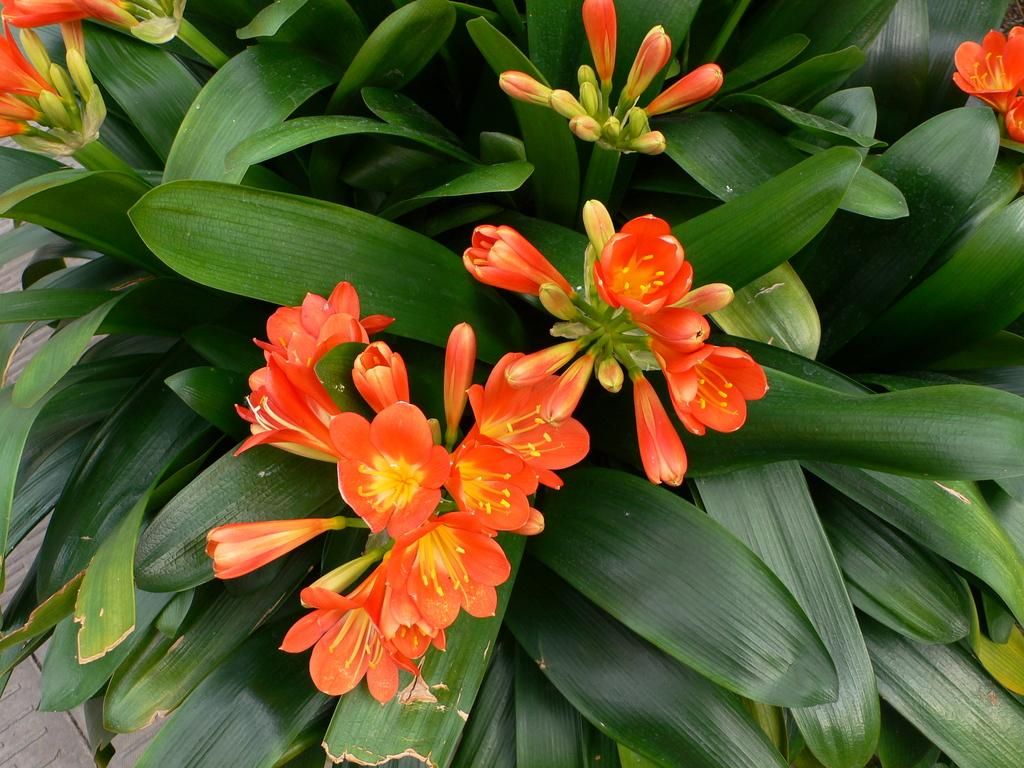What is the main subject in the center of the image? There are flowers in the center of the image. What else can be seen in the image besides the flowers? There are leaves in the image. How does the milk flow through the knot in the image? There is no milk or knot present in the image; it only features flowers and leaves. 